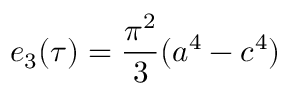<formula> <loc_0><loc_0><loc_500><loc_500>e _ { 3 } ( \tau ) = { \frac { \pi ^ { 2 } } { 3 } } ( a ^ { 4 } - c ^ { 4 } )</formula> 